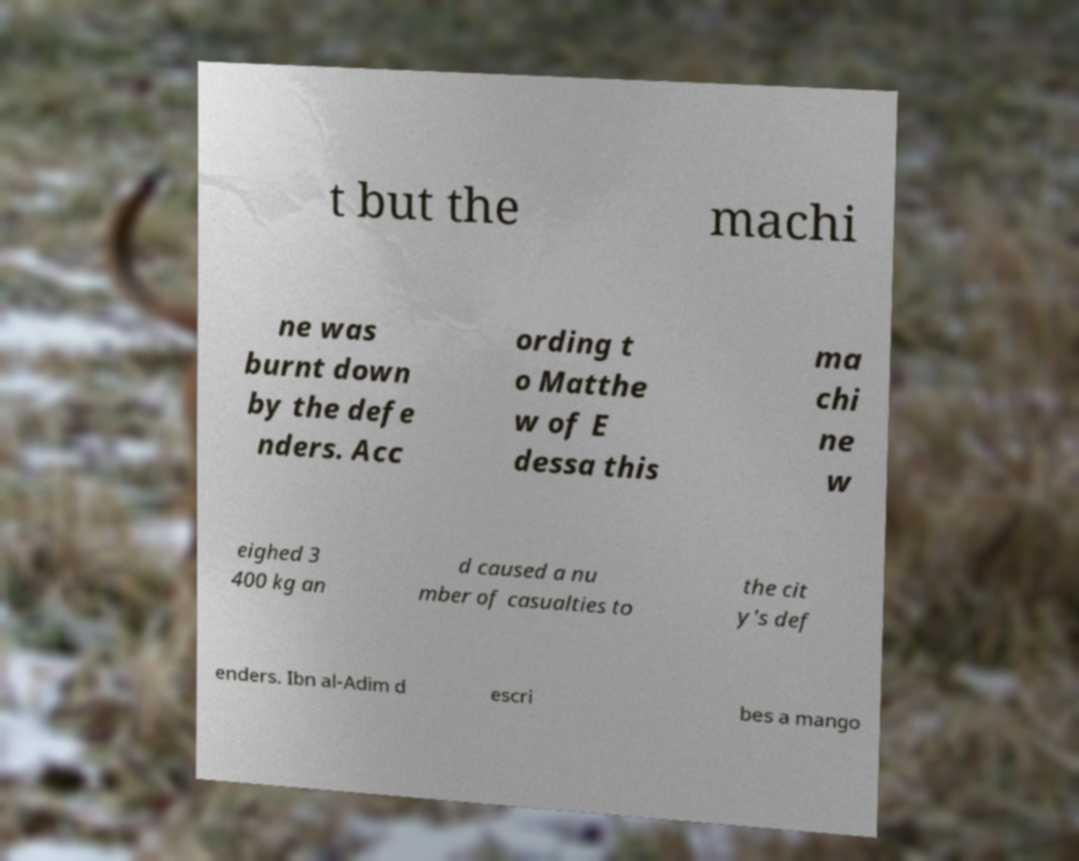Could you assist in decoding the text presented in this image and type it out clearly? t but the machi ne was burnt down by the defe nders. Acc ording t o Matthe w of E dessa this ma chi ne w eighed 3 400 kg an d caused a nu mber of casualties to the cit y's def enders. Ibn al-Adim d escri bes a mango 